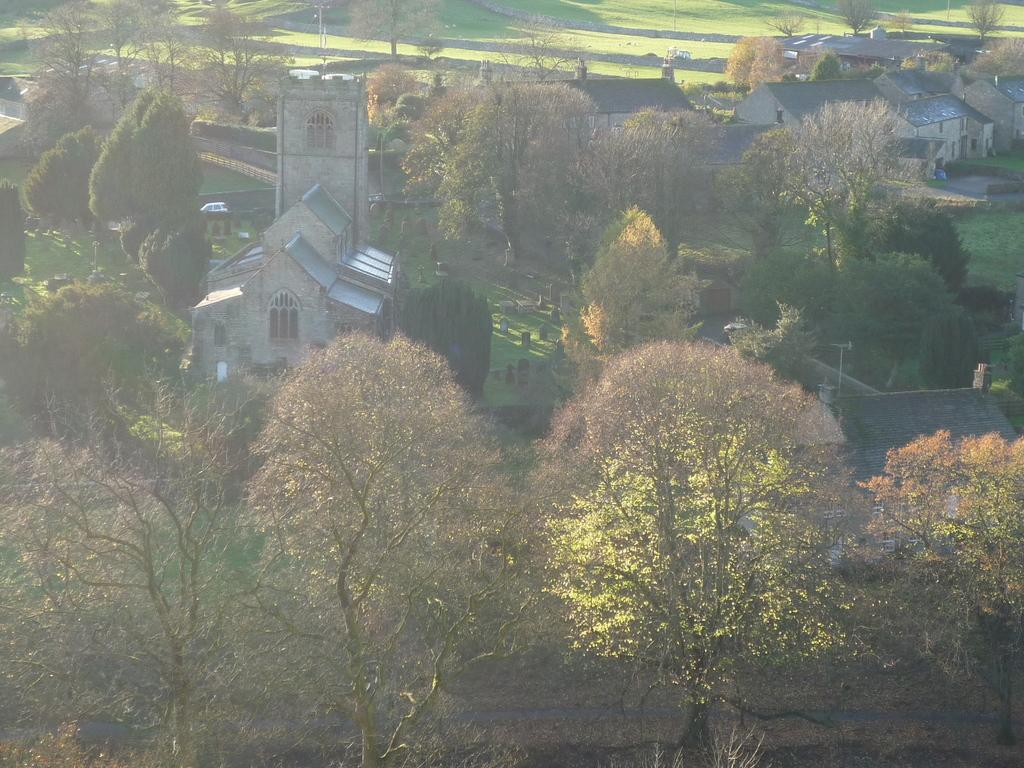What type of vegetation is present in the image? There are many trees in the image. What type of structures can be seen in the image? There are buildings with roofs, walls, windows, and pillars in the image. What is on the ground in the image? There is grass and graves on the ground in the image. What type of music can be heard playing in the background of the image? There is no music present in the image, as it is a still image and does not have any audio. 